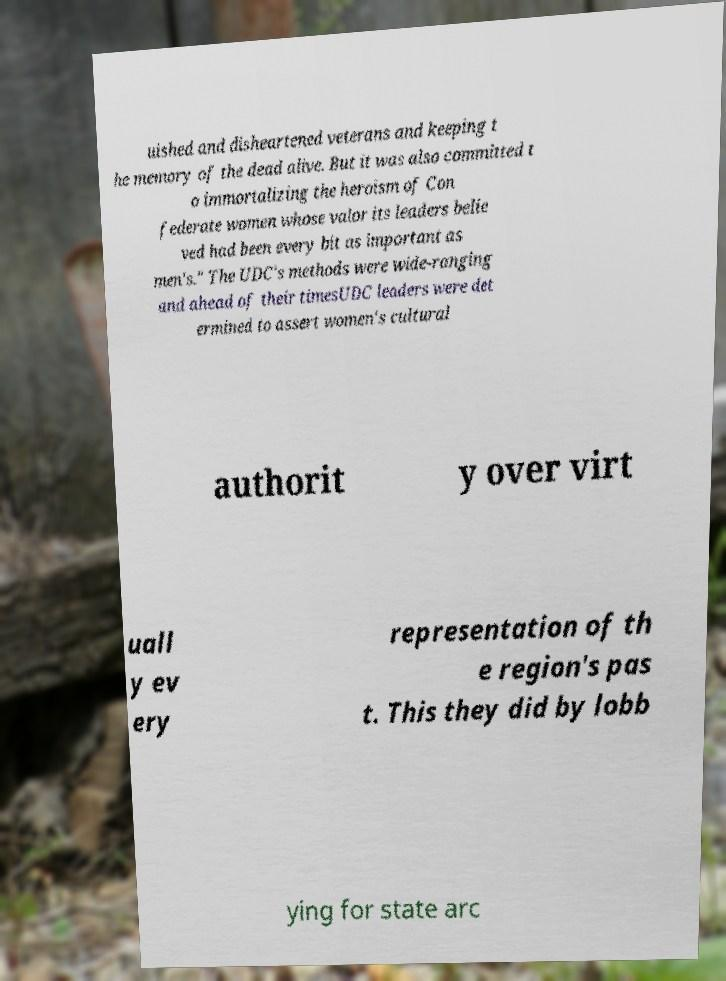Can you accurately transcribe the text from the provided image for me? uished and disheartened veterans and keeping t he memory of the dead alive. But it was also committed t o immortalizing the heroism of Con federate women whose valor its leaders belie ved had been every bit as important as men's." The UDC's methods were wide-ranging and ahead of their timesUDC leaders were det ermined to assert women's cultural authorit y over virt uall y ev ery representation of th e region's pas t. This they did by lobb ying for state arc 